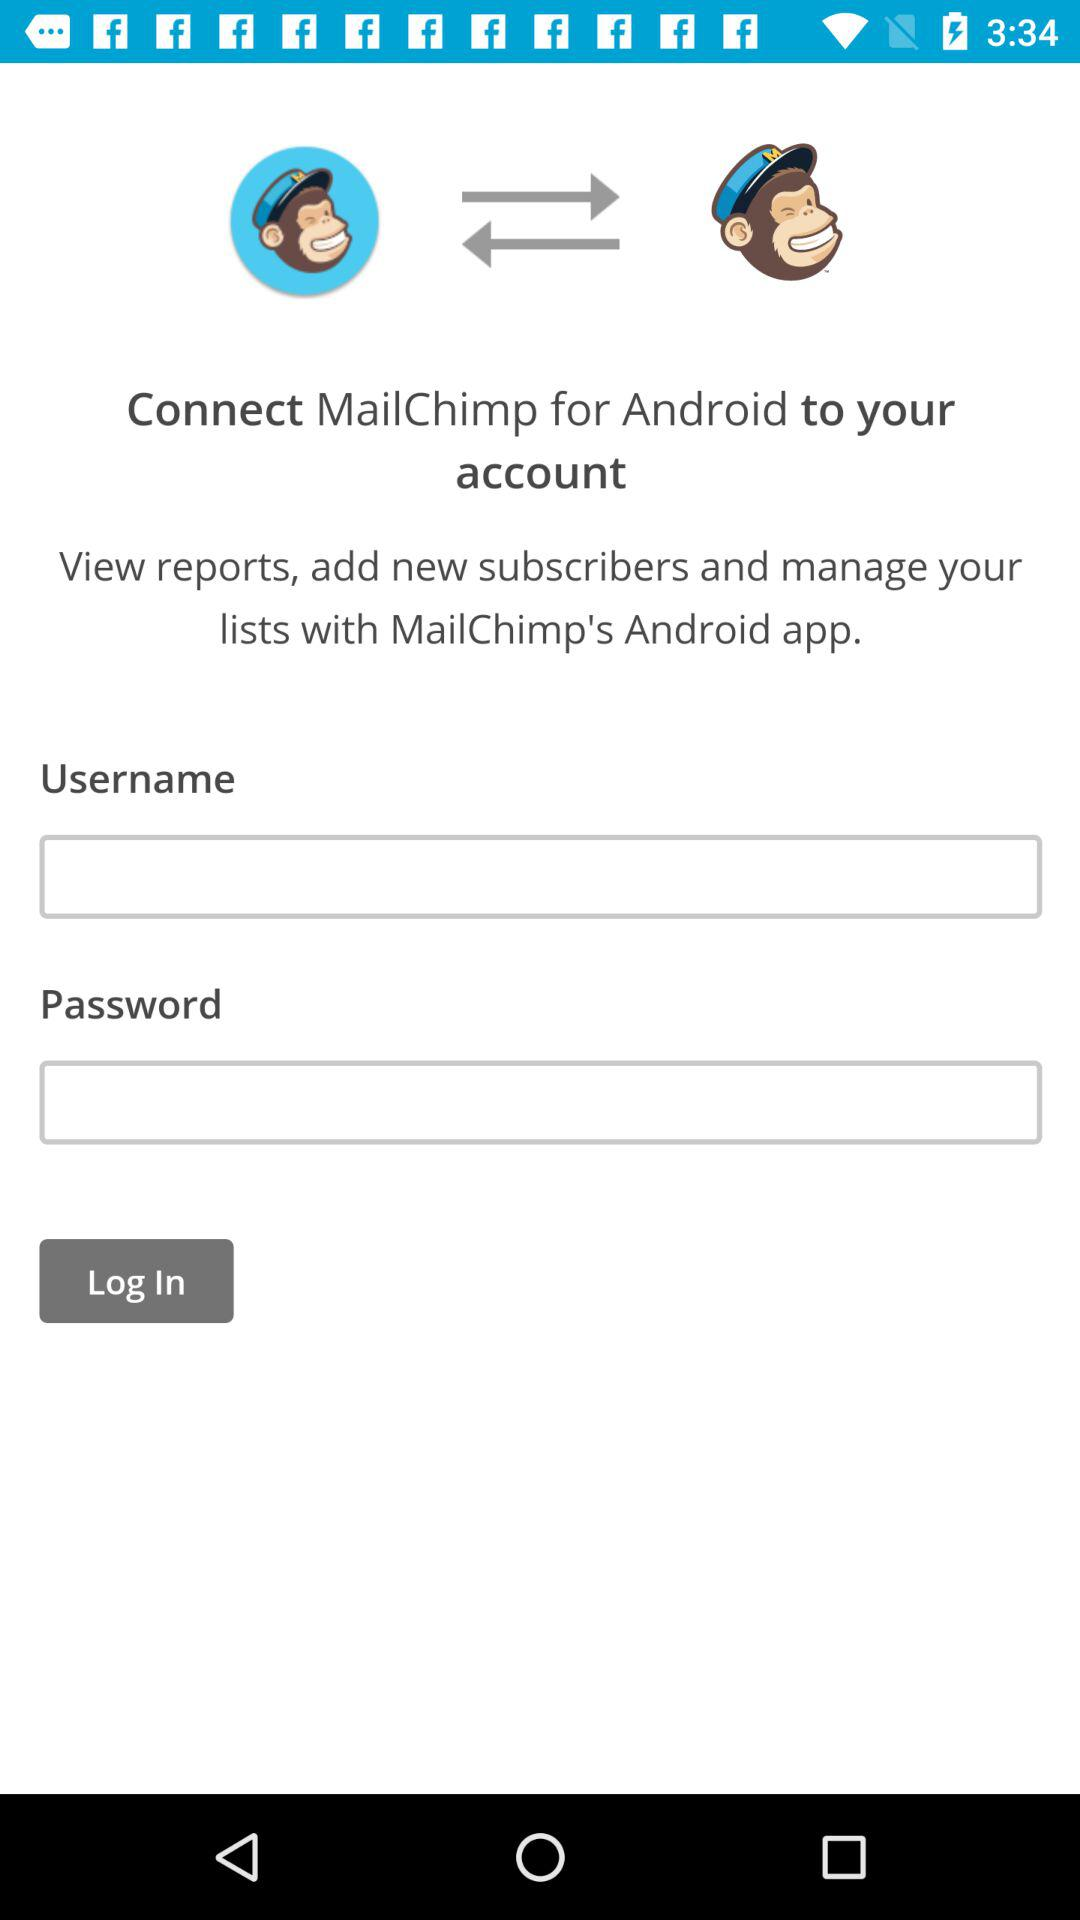How many text inputs are on the screen?
Answer the question using a single word or phrase. 2 